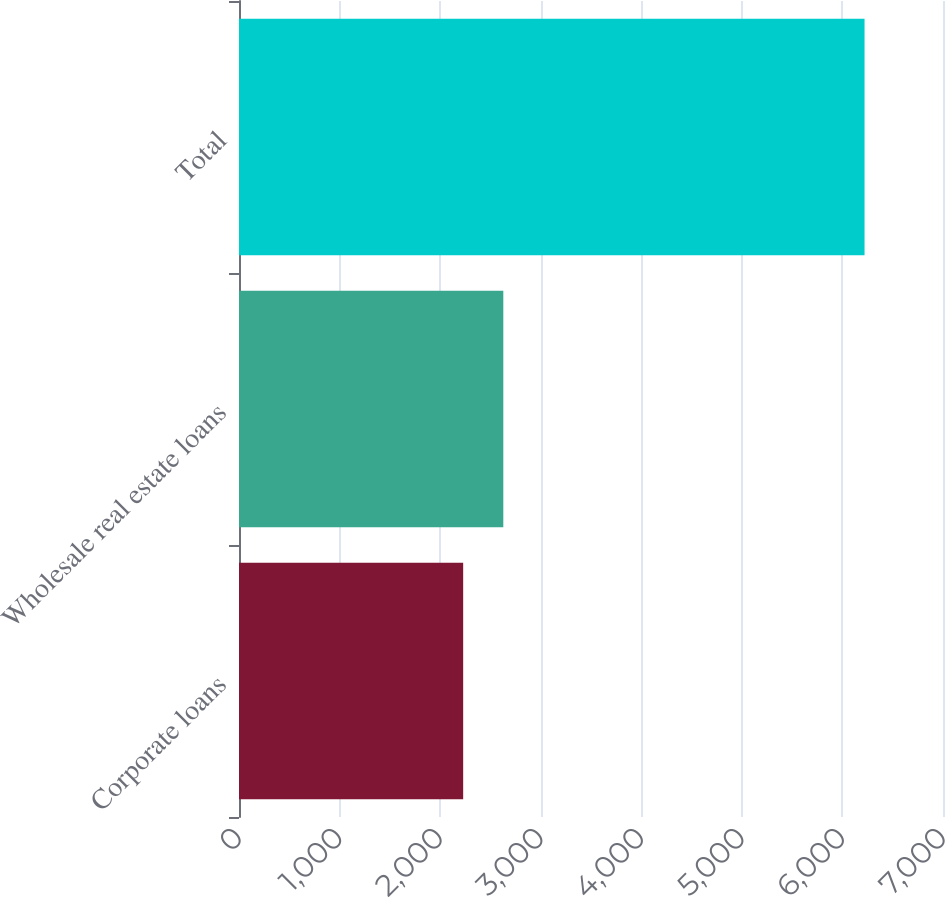Convert chart. <chart><loc_0><loc_0><loc_500><loc_500><bar_chart><fcel>Corporate loans<fcel>Wholesale real estate loans<fcel>Total<nl><fcel>2229<fcel>2628.1<fcel>6220<nl></chart> 